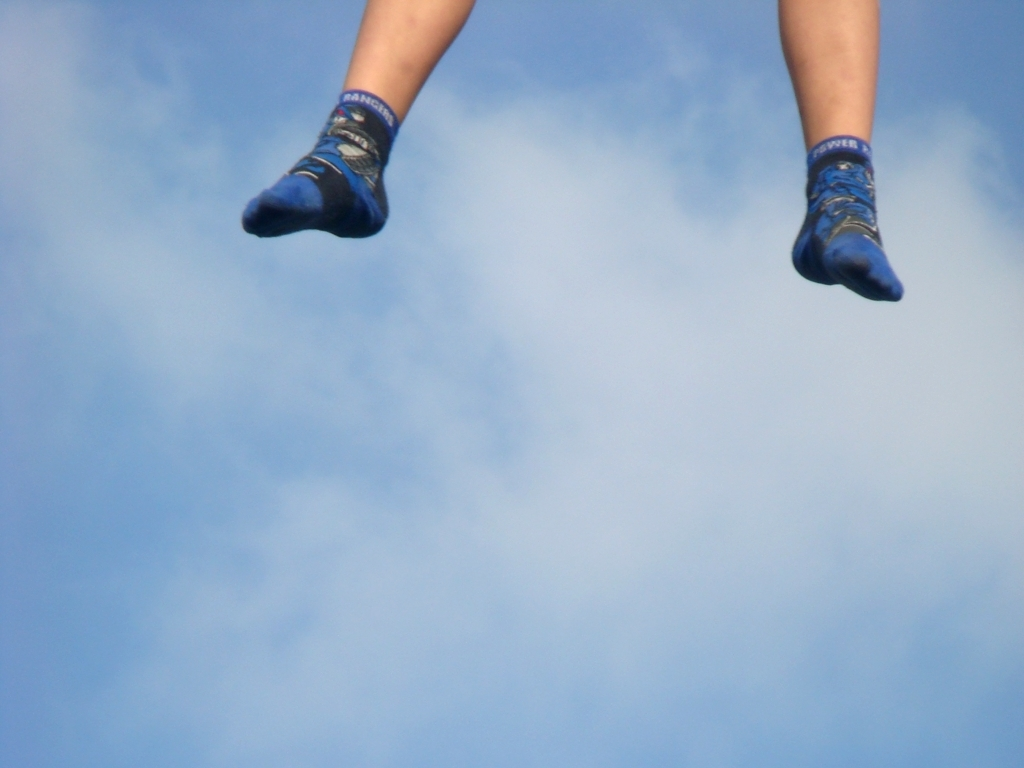Are the patterns on the socks clearly visible? While the patterns on the socks are somewhat discernible, the details are not entirely clear due to the motion blur and the distance from the camera. The socks appear to be blue with some graphics and text that might indicate a brand or a thematic design, but specific details of the pattern cannot be confidently identified from this image. 